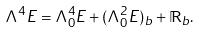<formula> <loc_0><loc_0><loc_500><loc_500>\Lambda ^ { 4 } E = \Lambda ^ { 4 } _ { 0 } E + ( \Lambda _ { 0 } ^ { 2 } E ) _ { b } + \mathbb { R } _ { b } .</formula> 